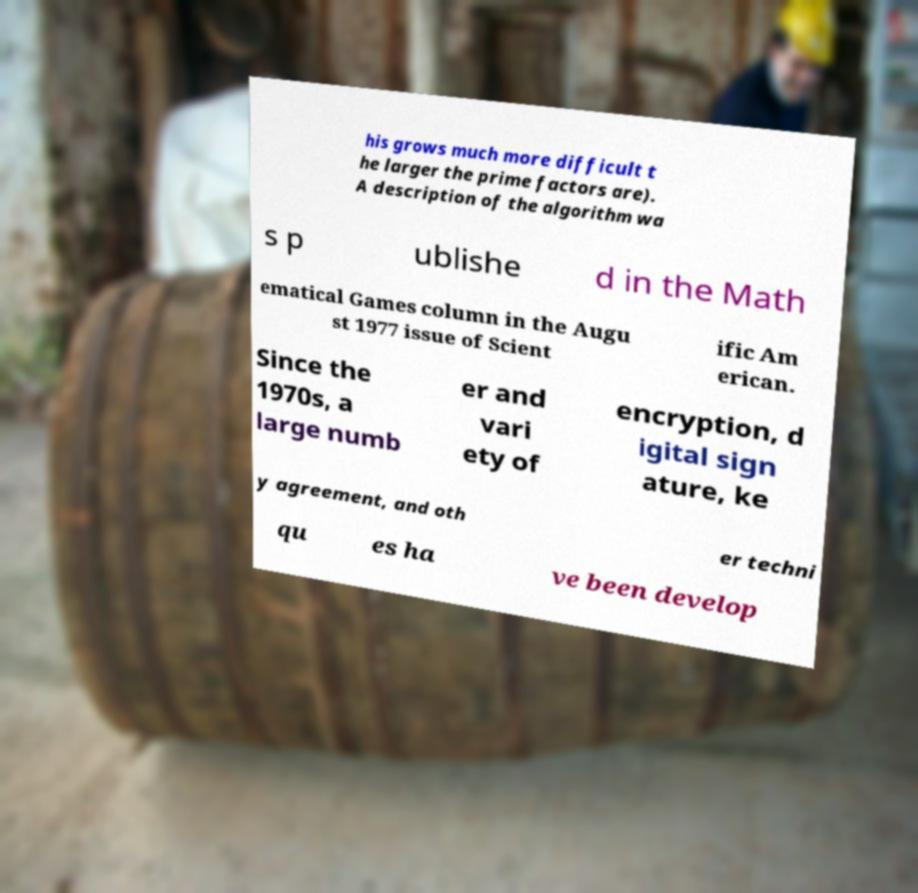There's text embedded in this image that I need extracted. Can you transcribe it verbatim? his grows much more difficult t he larger the prime factors are). A description of the algorithm wa s p ublishe d in the Math ematical Games column in the Augu st 1977 issue of Scient ific Am erican. Since the 1970s, a large numb er and vari ety of encryption, d igital sign ature, ke y agreement, and oth er techni qu es ha ve been develop 